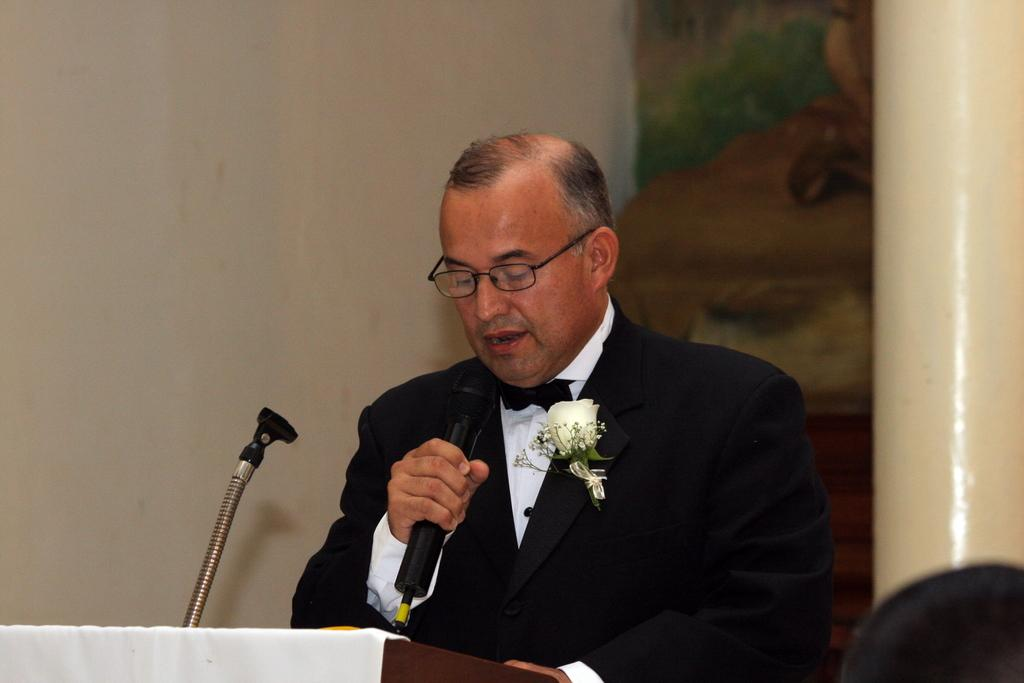What is the man in the image holding? The man is holding a microphone. What is the man wearing in the image? The man is wearing a suit with a flower on it and spectacles. What is in front of the man in the image? There is a podium with a stand in front of the man. What can be seen in the background of the image? There is a wall and a pillar in the background of the image. How many dinosaurs are visible in the image? There are no dinosaurs present in the image. What type of respect is being shown by the man in the image? The image does not provide information about the man's respect or attitude, so it cannot be determined from the image. 